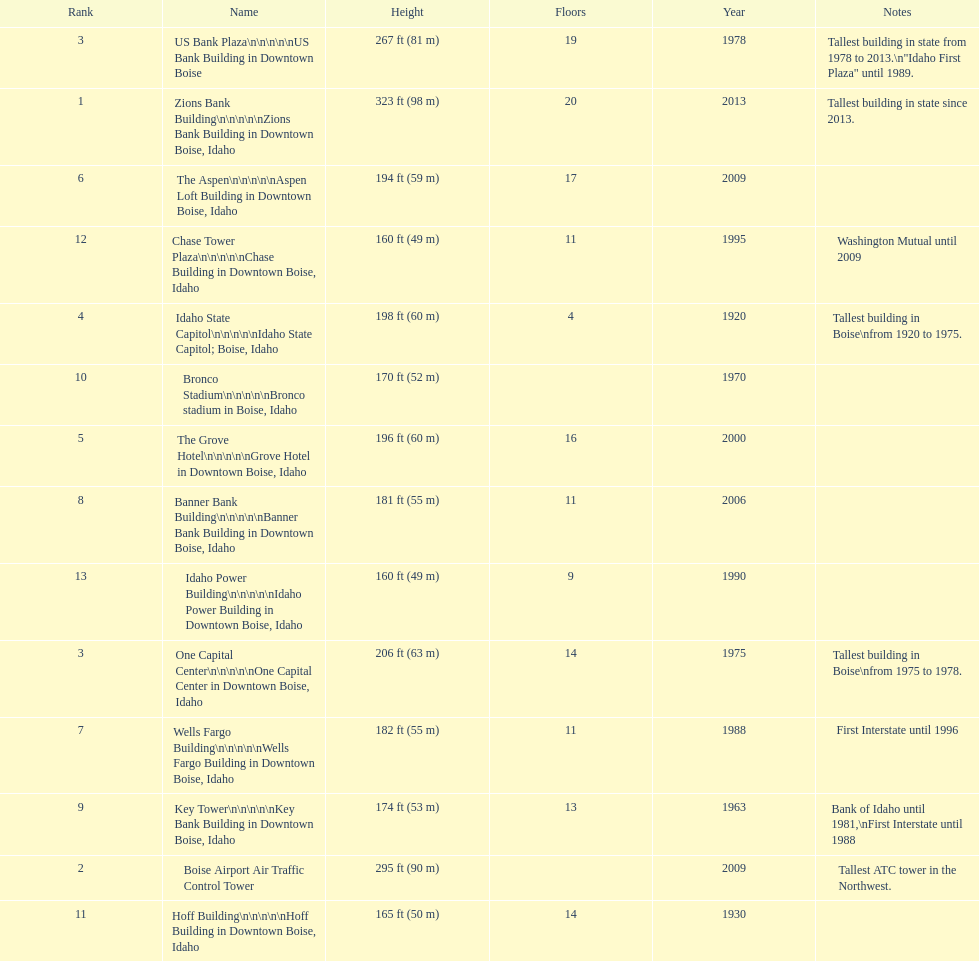How tall (in meters) is the tallest building? 98 m. 